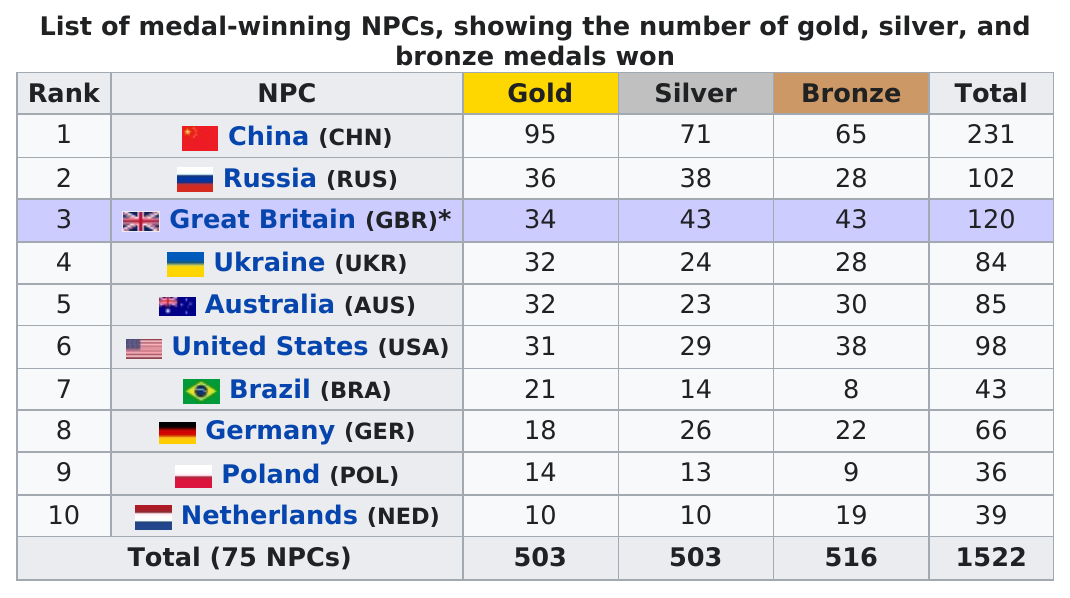Specify some key components in this picture. Australia won a total of 85 medals during the games. Australia won more medals than the United States, but fewer than Ukraine. The Netherlands won a total of 39 medals. Germany won a total of 44 gold and silver medals in the most recent Olympic Games. Brazil (BRA) has won the least amount of bronze medals among all countries. 